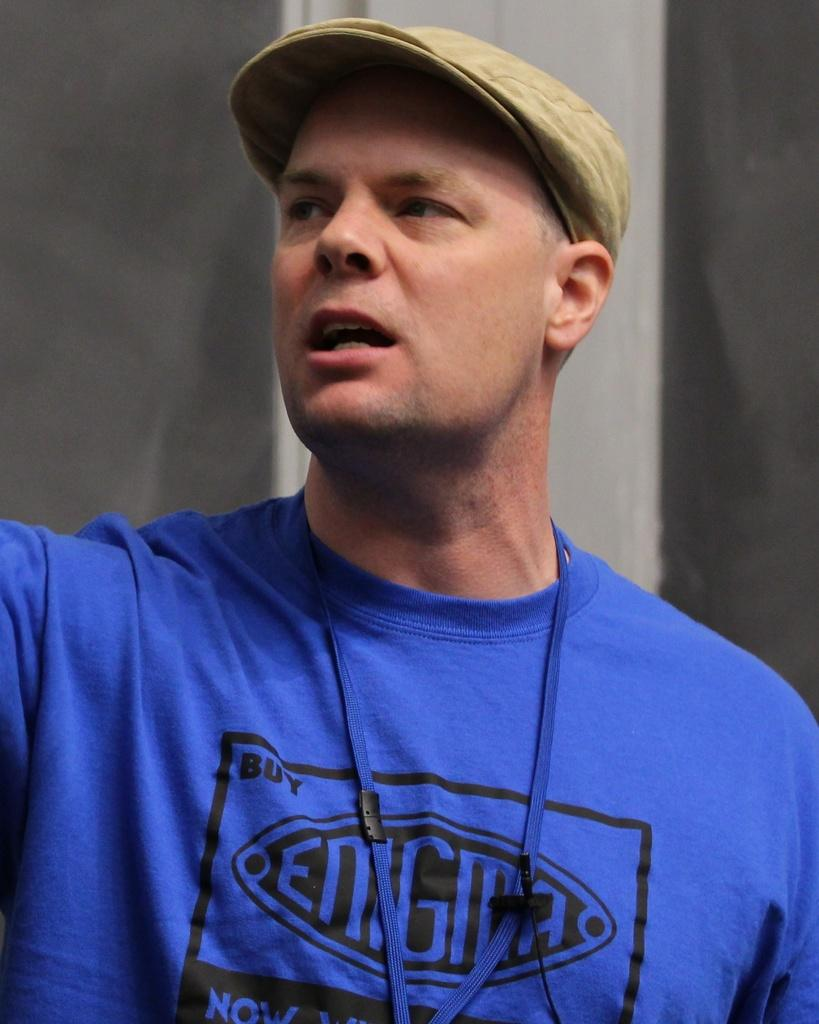Provide a one-sentence caption for the provided image. A man with a blue shirt that says Enigma, is wearing a brown hat. 